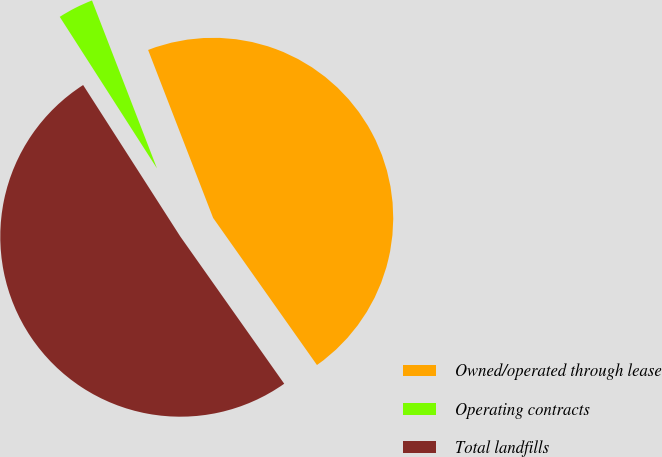Convert chart to OTSL. <chart><loc_0><loc_0><loc_500><loc_500><pie_chart><fcel>Owned/operated through lease<fcel>Operating contracts<fcel>Total landfills<nl><fcel>46.09%<fcel>3.2%<fcel>50.7%<nl></chart> 